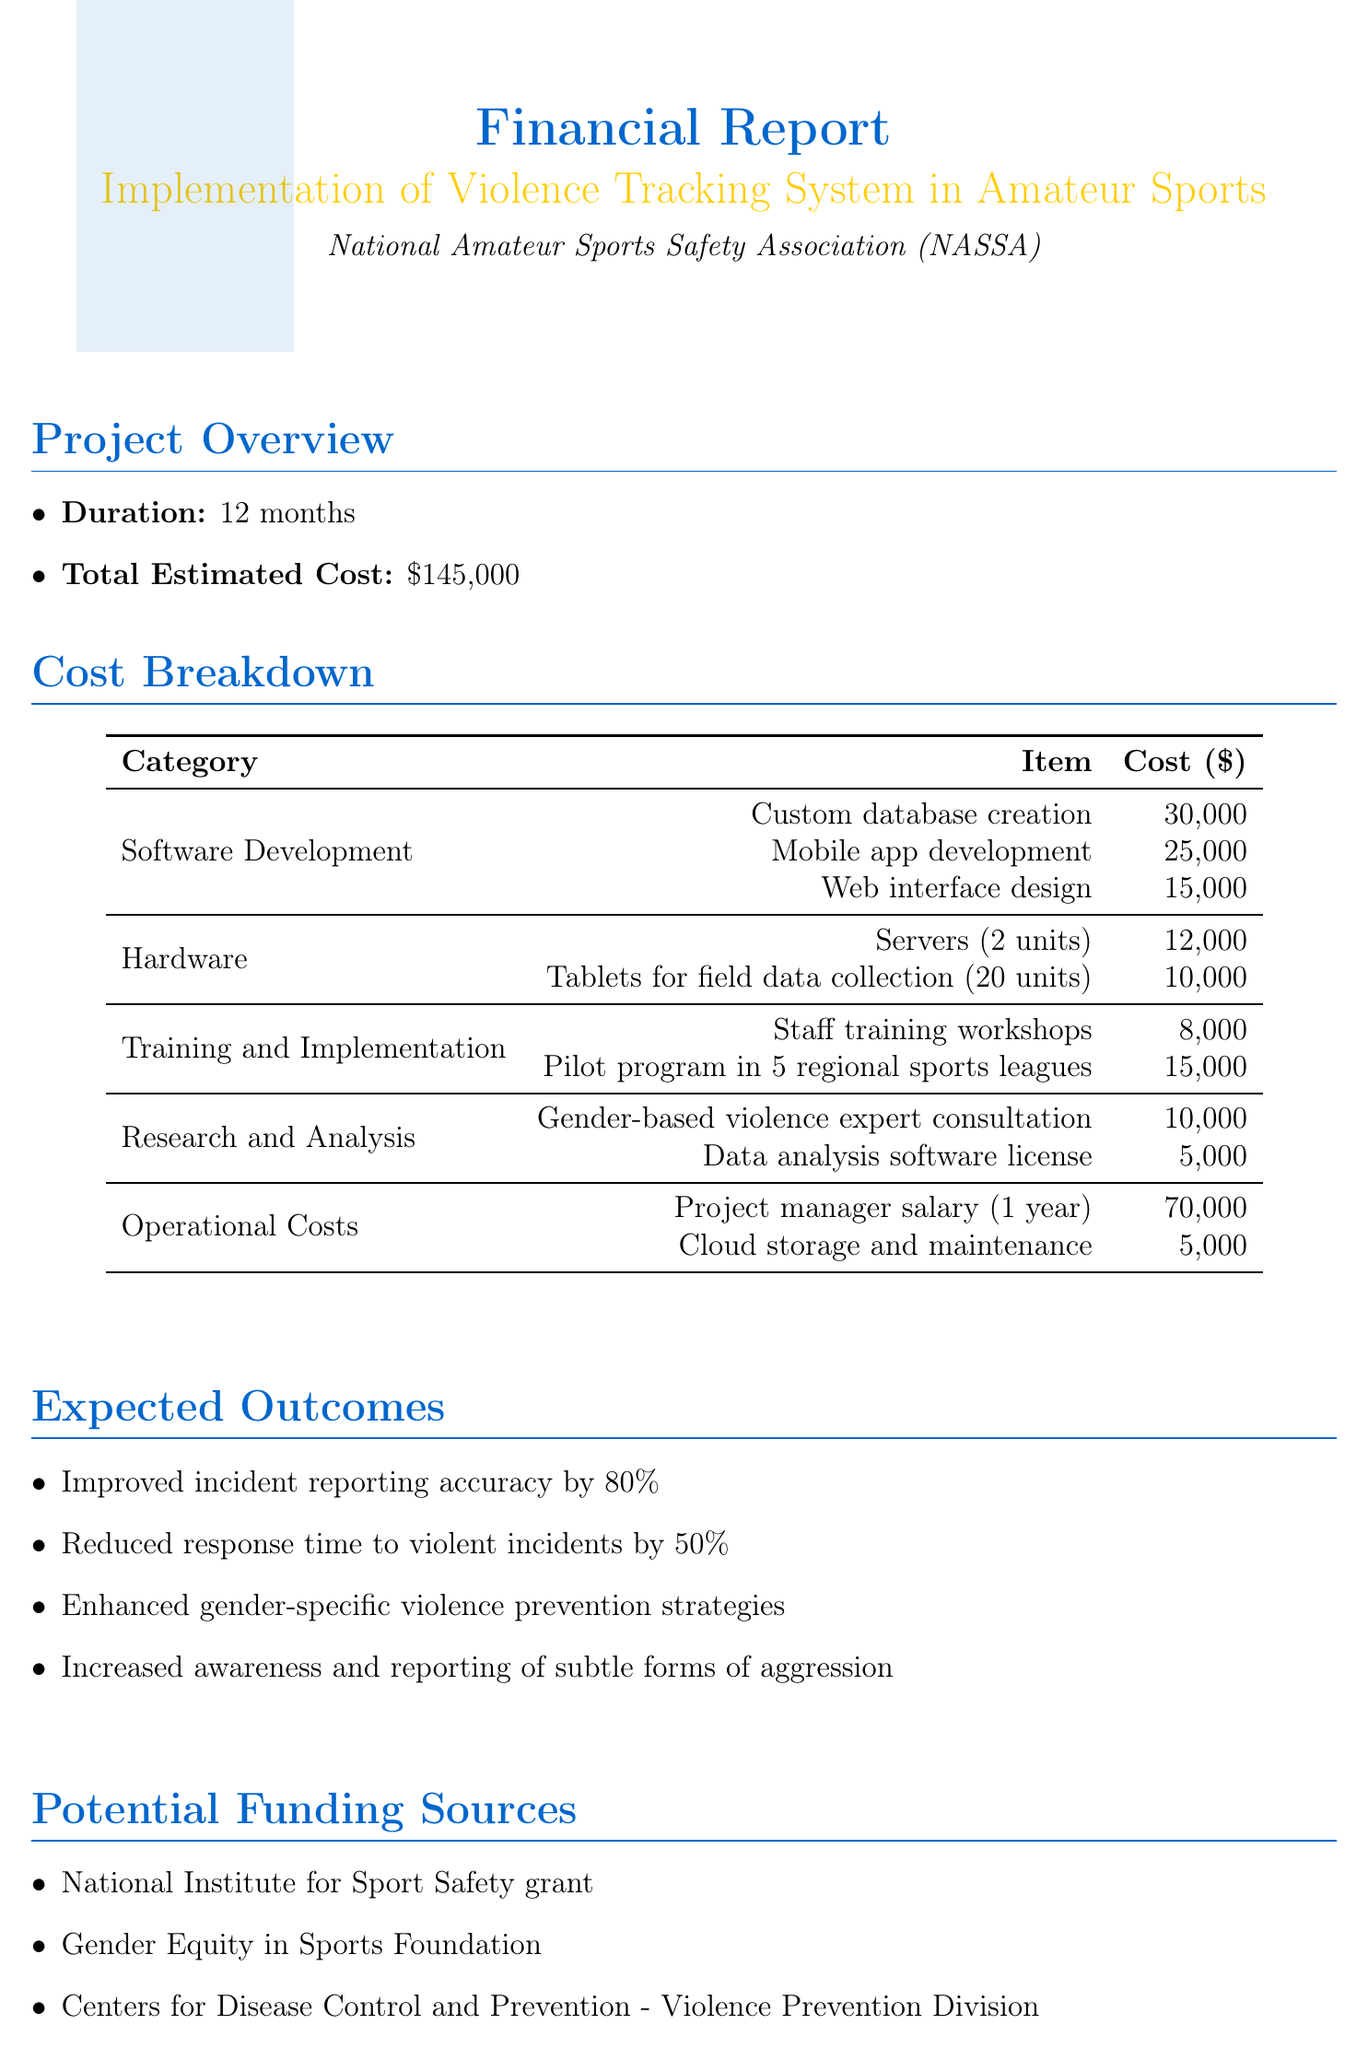what is the total estimated cost? The total estimated cost is provided in the project overview section of the document, which is $145,000.
Answer: $145,000 how long is the project duration? The duration of the project is specified in the project overview section, which states it is 12 months.
Answer: 12 months what is the cost of custom database creation? The cost of custom database creation is listed under the software development category, which is $30,000.
Answer: $30,000 which organization is implementing the system? The organization responsible for the implementation, mentioned in the title, is the National Amateur Sports Safety Association (NASSA).
Answer: National Amateur Sports Safety Association (NASSA) how much will be spent on training workshops? The cost for staff training workshops is found in the training and implementation category, which is $8,000.
Answer: $8,000 what is one expected outcome of the project? The expected outcomes are listed in a bullet point format, and one of them is improved incident reporting accuracy by 80%.
Answer: Improved incident reporting accuracy by 80% how many units of tablets are needed for data collection? The number of tablets required for field data collection is specified in the hardware category, which is 20 units.
Answer: 20 units which funding source is related to gender equity? One of the funding sources mentioned directly relates to gender equity, titled the Gender Equity in Sports Foundation.
Answer: Gender Equity in Sports Foundation what is the total cost for operational costs? The operational costs section lists costs that should be summed to provide the total operational costs, which are $70,000 plus $5,000, totaling $75,000.
Answer: $75,000 